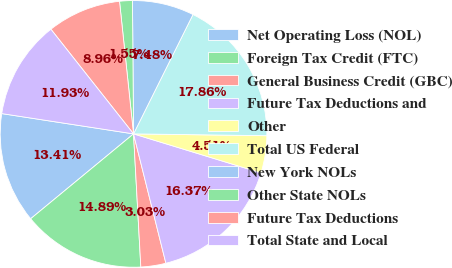Convert chart to OTSL. <chart><loc_0><loc_0><loc_500><loc_500><pie_chart><fcel>Net Operating Loss (NOL)<fcel>Foreign Tax Credit (FTC)<fcel>General Business Credit (GBC)<fcel>Future Tax Deductions and<fcel>Other<fcel>Total US Federal<fcel>New York NOLs<fcel>Other State NOLs<fcel>Future Tax Deductions<fcel>Total State and Local<nl><fcel>13.41%<fcel>14.89%<fcel>3.03%<fcel>16.37%<fcel>4.51%<fcel>17.86%<fcel>7.48%<fcel>1.55%<fcel>8.96%<fcel>11.93%<nl></chart> 